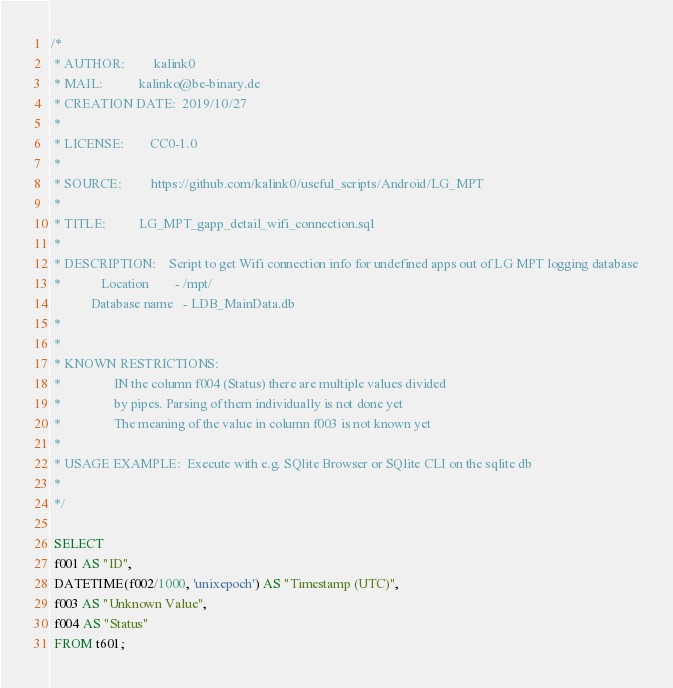Convert code to text. <code><loc_0><loc_0><loc_500><loc_500><_SQL_>/*
 * AUTHOR:         kalink0
 * MAIL:           kalinko@be-binary.de
 * CREATION DATE:  2019/10/27
 *
 * LICENSE:        CC0-1.0
 *
 * SOURCE:         https://github.com/kalink0/useful_scripts/Android/LG_MPT
 *
 * TITLE:          LG_MPT_gapp_detail_wifi_connection.sql
 *
 * DESCRIPTION:    Script to get Wifi connection info for undefined apps out of LG MPT logging database
 *			Location 		- /mpt/
			Database name 	- LDB_MainData.db
 *
 *
 * KNOWN RESTRICTIONS:
 *                IN the column f004 (Status) there are multiple values divided
 *                by pipes. Parsing of them individually is not done yet
 *                The meaning of the value in column f003 is not known yet
 *
 * USAGE EXAMPLE:  Execute with e.g. SQlite Browser or SQlite CLI on the sqlite db
 *
 */

 SELECT
 f001 AS "ID",
 DATETIME(f002/1000, 'unixepoch') AS "Timestamp (UTC)",
 f003 AS "Unknown Value",
 f004 AS "Status"
 FROM t601;
</code> 